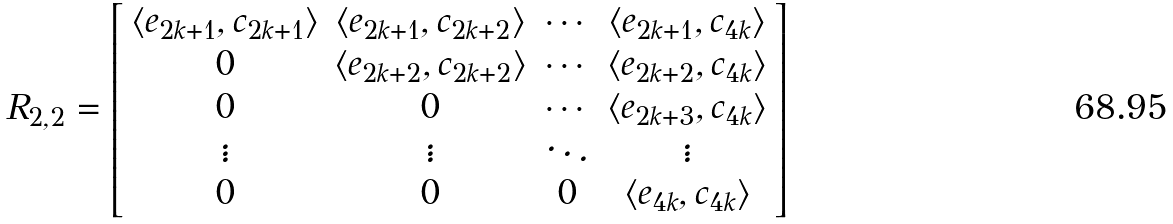<formula> <loc_0><loc_0><loc_500><loc_500>R _ { 2 , 2 } = \left [ \begin{array} { c c c c c } \langle e _ { 2 k + 1 } , c _ { 2 k + 1 } \rangle & \langle e _ { 2 k + 1 } , c _ { 2 k + 2 } \rangle & \cdots & \langle e _ { 2 k + 1 } , c _ { 4 k } \rangle \\ 0 & \langle e _ { 2 k + 2 } , c _ { 2 k + 2 } \rangle & \cdots & \langle e _ { 2 k + 2 } , c _ { 4 k } \rangle \\ 0 & 0 & \cdots & \langle e _ { 2 k + 3 } , c _ { 4 k } \rangle \\ \vdots & \vdots & \ddots & \vdots \\ 0 & 0 & 0 & \langle e _ { 4 k } , c _ { 4 k } \rangle \end{array} \right ]</formula> 